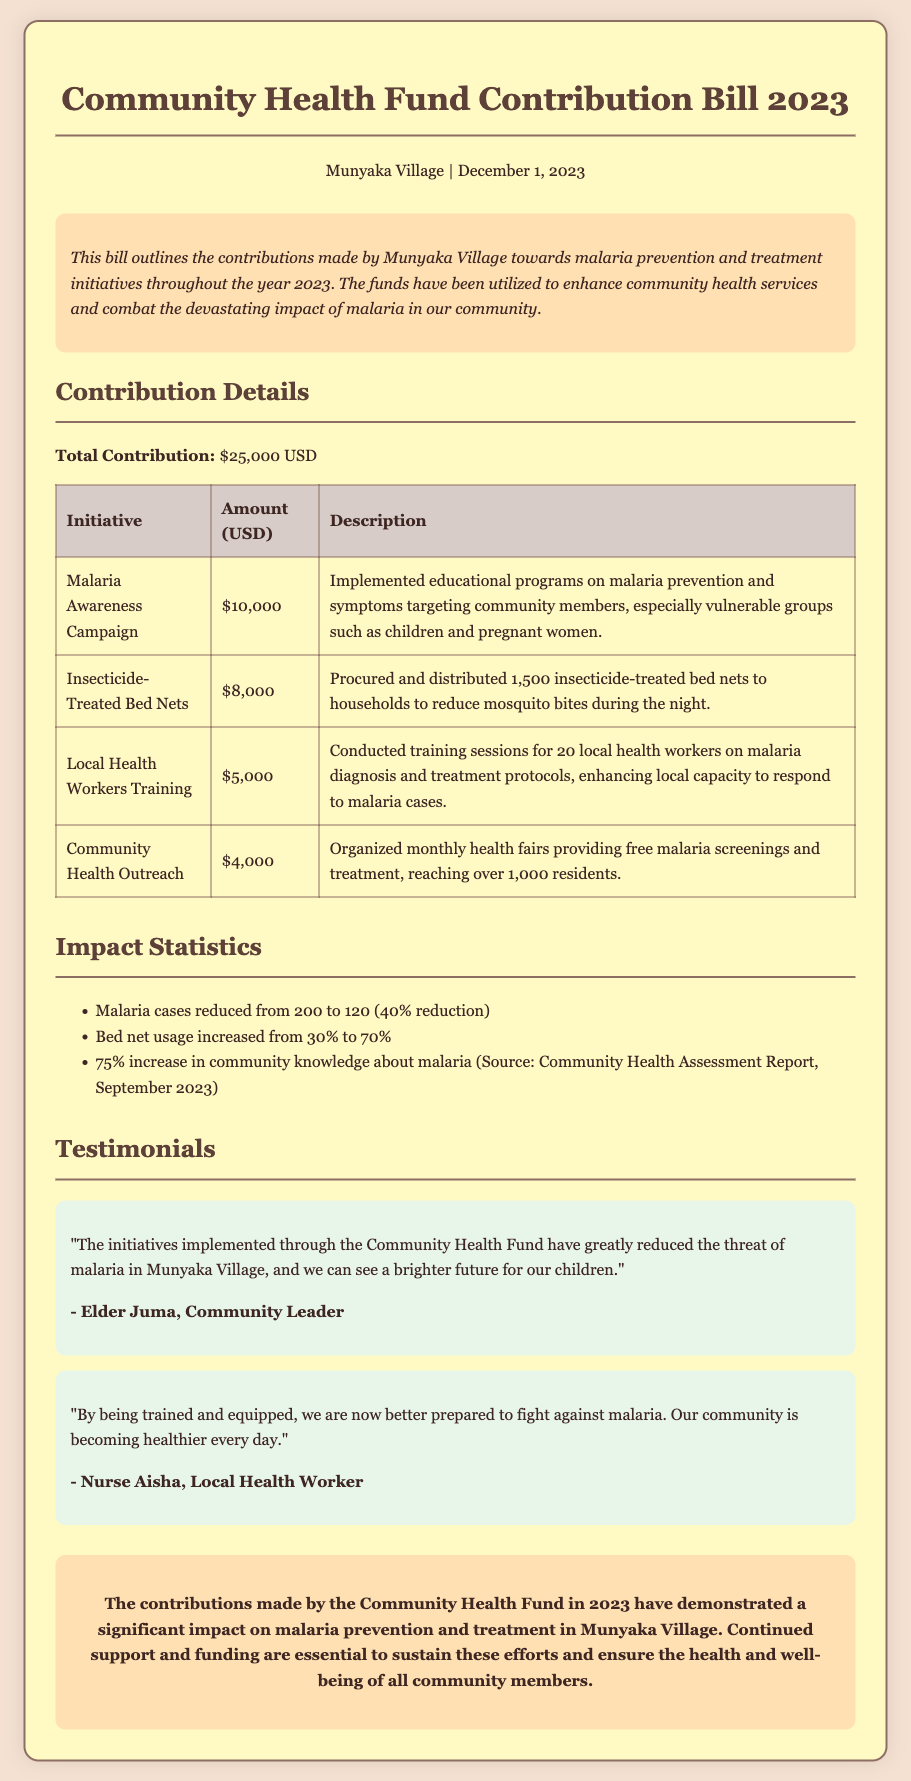What is the total contribution? The total contribution is stated in the document under Contribution Details.
Answer: $25,000 USD How much was allocated for the Malaria Awareness Campaign? The amount allocated for the Malaria Awareness Campaign is specified in the table under Contribution Details.
Answer: $10,000 What percentage reduction in malaria cases was reported? The percentage reduction in malaria cases is mentioned in the Impact Statistics section.
Answer: 40% How many insecticide-treated bed nets were distributed? The number of insecticide-treated bed nets distributed is noted in the Contribution Details table.
Answer: 1,500 Who is the community leader that provided a testimonial? The name of the community leader who provided a testimonial is indicated in the Testimonials section.
Answer: Elder Juma What was the budget for training local health workers? The budget for training local health workers is listed in the Contribution Details table.
Answer: $5,000 How many residents were reached by the monthly health fairs? The number of residents reached by the health fairs is mentioned in the Contribution Details section.
Answer: Over 1,000 What was the increase in community knowledge about malaria? The increase in community knowledge about malaria is specified in the Impact Statistics section.
Answer: 75% 